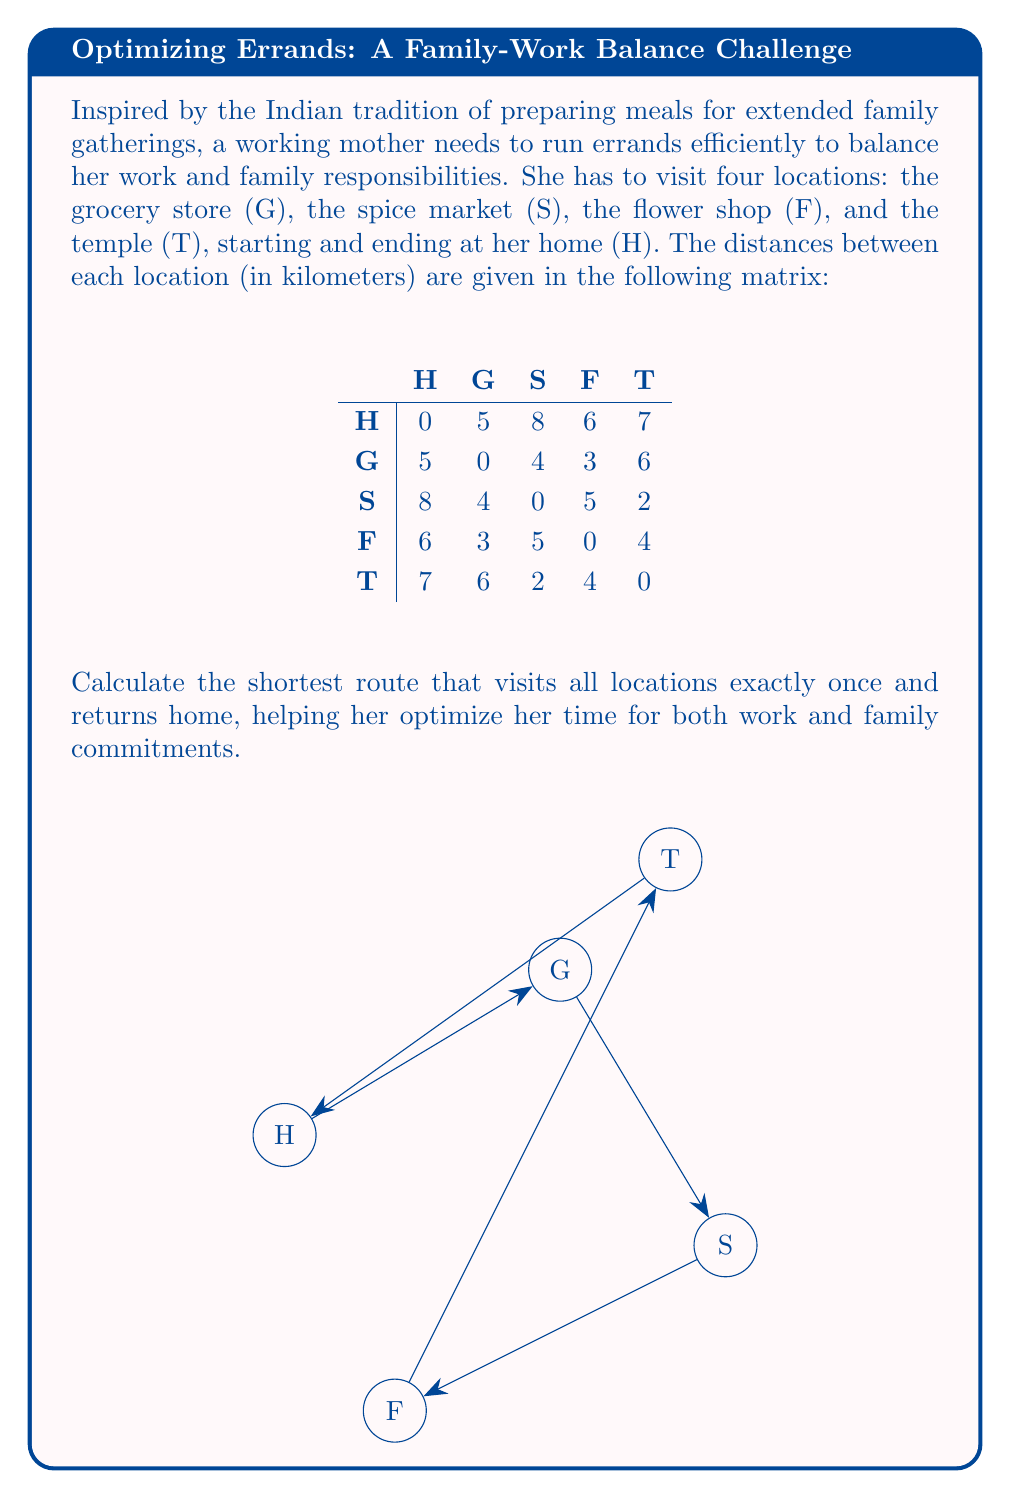Could you help me with this problem? To solve this problem, we can use the Traveling Salesman Problem (TSP) approach. Since there are only 5 locations, we can use the brute force method to find the optimal solution.

Step 1: List all possible routes
There are (5-1)! = 24 possible routes, as the starting and ending point (H) is fixed.

Step 2: Calculate the total distance for each route
Let's calculate a few examples:
H-G-S-F-T-H: 5 + 4 + 5 + 4 + 7 = 25 km
H-G-S-T-F-H: 5 + 4 + 2 + 4 + 6 = 21 km
H-T-S-G-F-H: 7 + 2 + 4 + 3 + 6 = 22 km

Step 3: Find the route with the minimum total distance
After calculating all 24 routes, we find that the shortest route is:

H-G-F-T-S-H

Step 4: Calculate the total distance of the optimal route
H to G: 5 km
G to F: 3 km
F to T: 4 km
T to S: 2 km
S to H: 8 km

Total distance = 5 + 3 + 4 + 2 + 8 = 22 km

Therefore, the most efficient route for the working mother to run her errands is Home - Grocery store - Flower shop - Temple - Spice market - Home, with a total distance of 22 km.
Answer: H-G-F-T-S-H, 22 km 